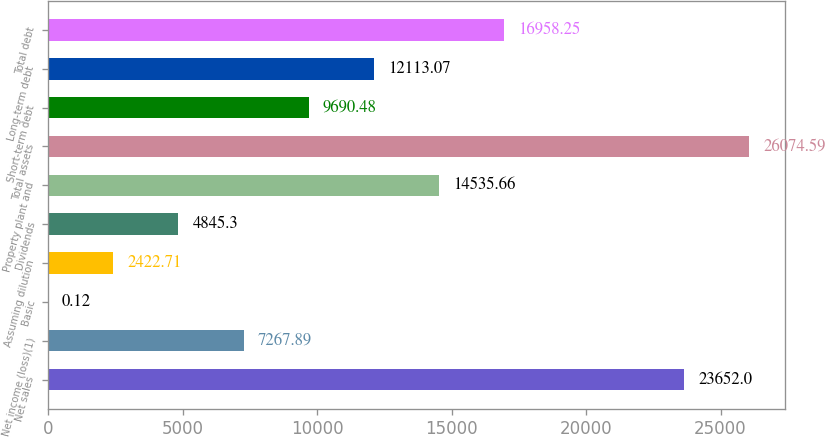Convert chart to OTSL. <chart><loc_0><loc_0><loc_500><loc_500><bar_chart><fcel>Net sales<fcel>Net income (loss)(1)<fcel>Basic<fcel>Assuming dilution<fcel>Dividends<fcel>Property plant and<fcel>Total assets<fcel>Short-term debt<fcel>Long-term debt<fcel>Total debt<nl><fcel>23652<fcel>7267.89<fcel>0.12<fcel>2422.71<fcel>4845.3<fcel>14535.7<fcel>26074.6<fcel>9690.48<fcel>12113.1<fcel>16958.2<nl></chart> 